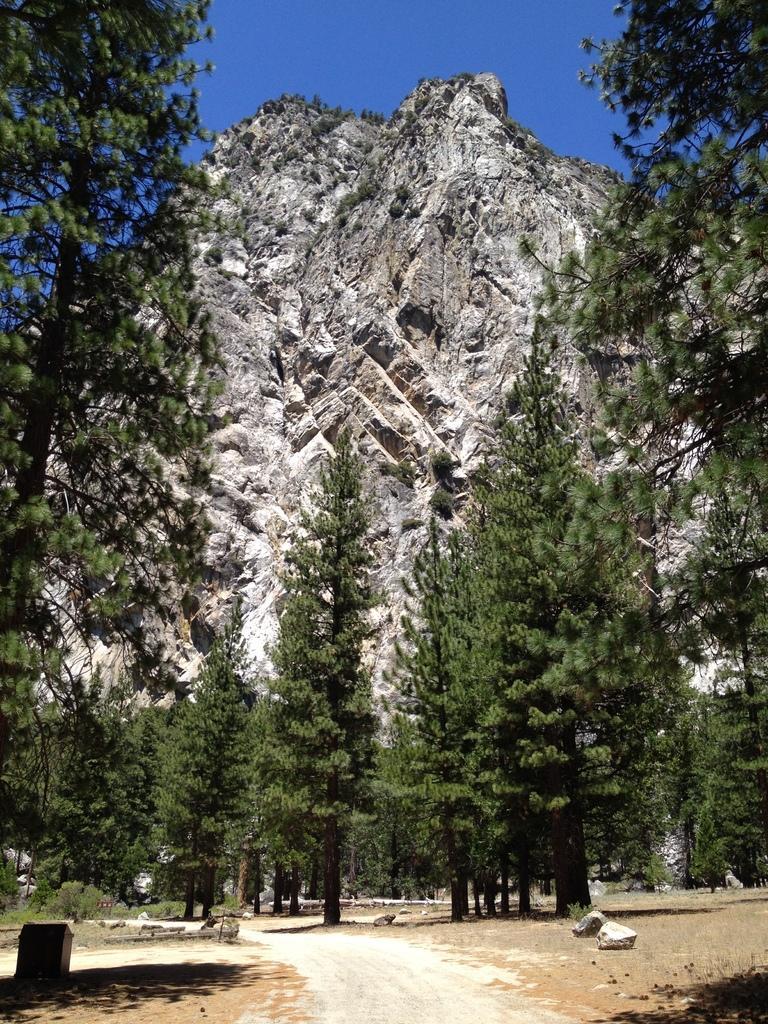In one or two sentences, can you explain what this image depicts? In this image I can see the rock's, many trees and the mountain. In the background I can see the blue sky. 